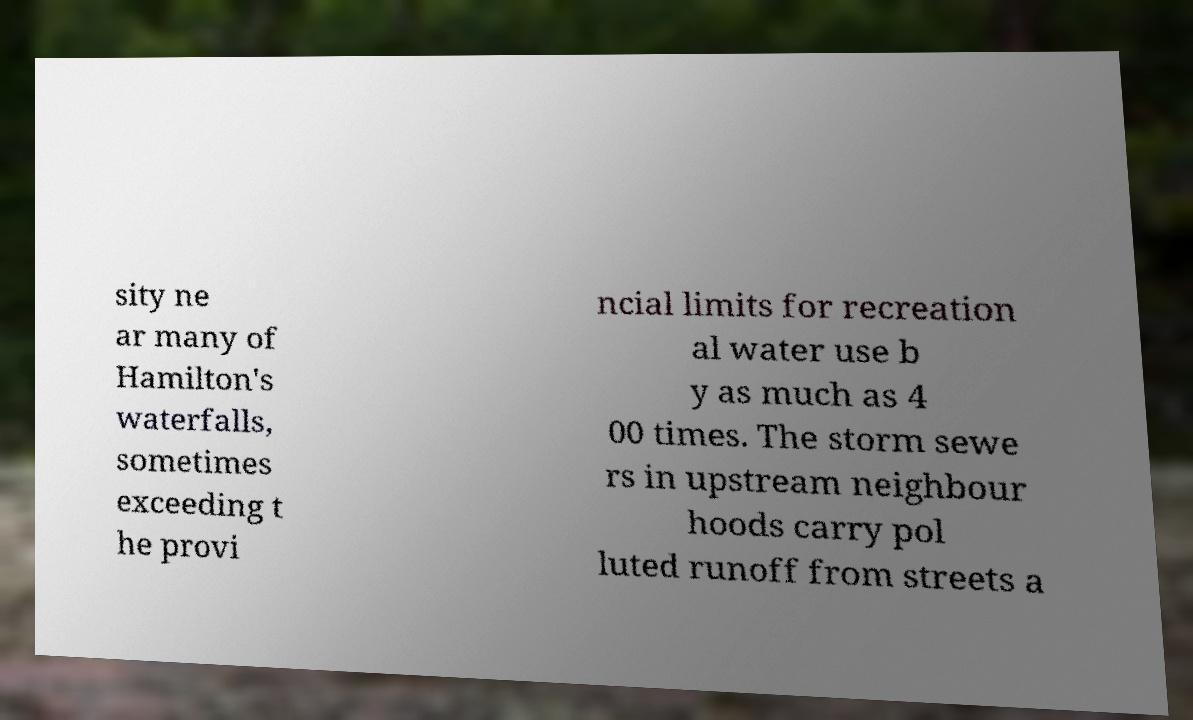There's text embedded in this image that I need extracted. Can you transcribe it verbatim? sity ne ar many of Hamilton's waterfalls, sometimes exceeding t he provi ncial limits for recreation al water use b y as much as 4 00 times. The storm sewe rs in upstream neighbour hoods carry pol luted runoff from streets a 